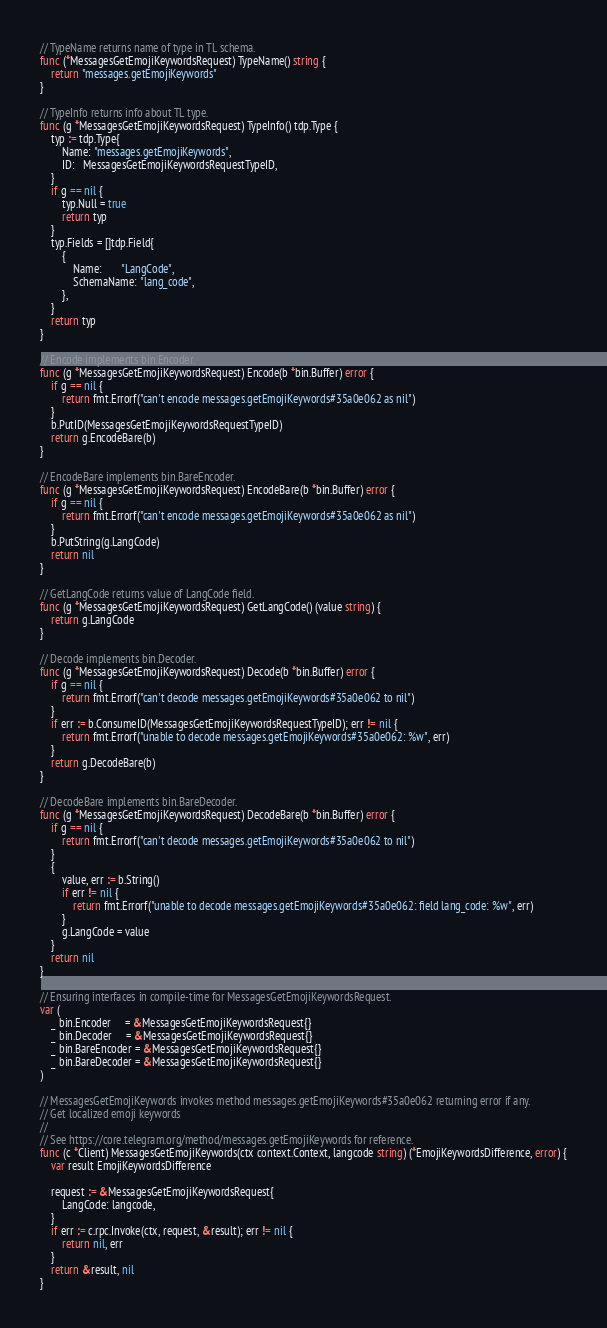<code> <loc_0><loc_0><loc_500><loc_500><_Go_>// TypeName returns name of type in TL schema.
func (*MessagesGetEmojiKeywordsRequest) TypeName() string {
	return "messages.getEmojiKeywords"
}

// TypeInfo returns info about TL type.
func (g *MessagesGetEmojiKeywordsRequest) TypeInfo() tdp.Type {
	typ := tdp.Type{
		Name: "messages.getEmojiKeywords",
		ID:   MessagesGetEmojiKeywordsRequestTypeID,
	}
	if g == nil {
		typ.Null = true
		return typ
	}
	typ.Fields = []tdp.Field{
		{
			Name:       "LangCode",
			SchemaName: "lang_code",
		},
	}
	return typ
}

// Encode implements bin.Encoder.
func (g *MessagesGetEmojiKeywordsRequest) Encode(b *bin.Buffer) error {
	if g == nil {
		return fmt.Errorf("can't encode messages.getEmojiKeywords#35a0e062 as nil")
	}
	b.PutID(MessagesGetEmojiKeywordsRequestTypeID)
	return g.EncodeBare(b)
}

// EncodeBare implements bin.BareEncoder.
func (g *MessagesGetEmojiKeywordsRequest) EncodeBare(b *bin.Buffer) error {
	if g == nil {
		return fmt.Errorf("can't encode messages.getEmojiKeywords#35a0e062 as nil")
	}
	b.PutString(g.LangCode)
	return nil
}

// GetLangCode returns value of LangCode field.
func (g *MessagesGetEmojiKeywordsRequest) GetLangCode() (value string) {
	return g.LangCode
}

// Decode implements bin.Decoder.
func (g *MessagesGetEmojiKeywordsRequest) Decode(b *bin.Buffer) error {
	if g == nil {
		return fmt.Errorf("can't decode messages.getEmojiKeywords#35a0e062 to nil")
	}
	if err := b.ConsumeID(MessagesGetEmojiKeywordsRequestTypeID); err != nil {
		return fmt.Errorf("unable to decode messages.getEmojiKeywords#35a0e062: %w", err)
	}
	return g.DecodeBare(b)
}

// DecodeBare implements bin.BareDecoder.
func (g *MessagesGetEmojiKeywordsRequest) DecodeBare(b *bin.Buffer) error {
	if g == nil {
		return fmt.Errorf("can't decode messages.getEmojiKeywords#35a0e062 to nil")
	}
	{
		value, err := b.String()
		if err != nil {
			return fmt.Errorf("unable to decode messages.getEmojiKeywords#35a0e062: field lang_code: %w", err)
		}
		g.LangCode = value
	}
	return nil
}

// Ensuring interfaces in compile-time for MessagesGetEmojiKeywordsRequest.
var (
	_ bin.Encoder     = &MessagesGetEmojiKeywordsRequest{}
	_ bin.Decoder     = &MessagesGetEmojiKeywordsRequest{}
	_ bin.BareEncoder = &MessagesGetEmojiKeywordsRequest{}
	_ bin.BareDecoder = &MessagesGetEmojiKeywordsRequest{}
)

// MessagesGetEmojiKeywords invokes method messages.getEmojiKeywords#35a0e062 returning error if any.
// Get localized emoji keywords
//
// See https://core.telegram.org/method/messages.getEmojiKeywords for reference.
func (c *Client) MessagesGetEmojiKeywords(ctx context.Context, langcode string) (*EmojiKeywordsDifference, error) {
	var result EmojiKeywordsDifference

	request := &MessagesGetEmojiKeywordsRequest{
		LangCode: langcode,
	}
	if err := c.rpc.Invoke(ctx, request, &result); err != nil {
		return nil, err
	}
	return &result, nil
}
</code> 